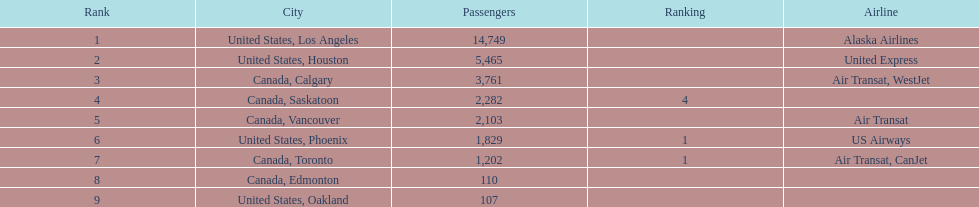What is the average number of passengers in the united states? 5537.5. 